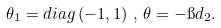Convert formula to latex. <formula><loc_0><loc_0><loc_500><loc_500>\theta _ { 1 } = d i a g \left ( - 1 , 1 \right ) \, , \, \theta = - \i d _ { 2 } .</formula> 